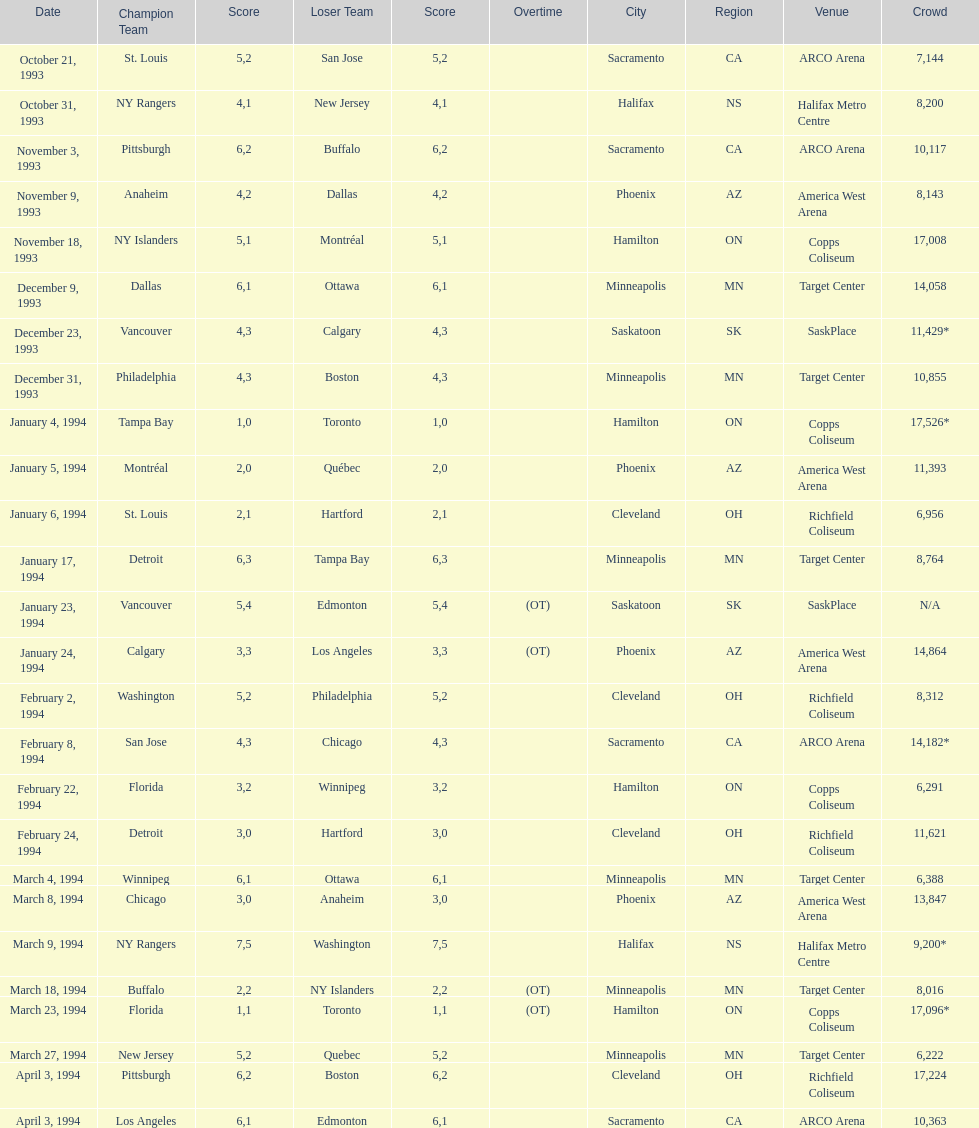Which event had higher attendance, january 24, 1994, or december 23, 1993? January 4, 1994. 